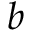Convert formula to latex. <formula><loc_0><loc_0><loc_500><loc_500>b</formula> 